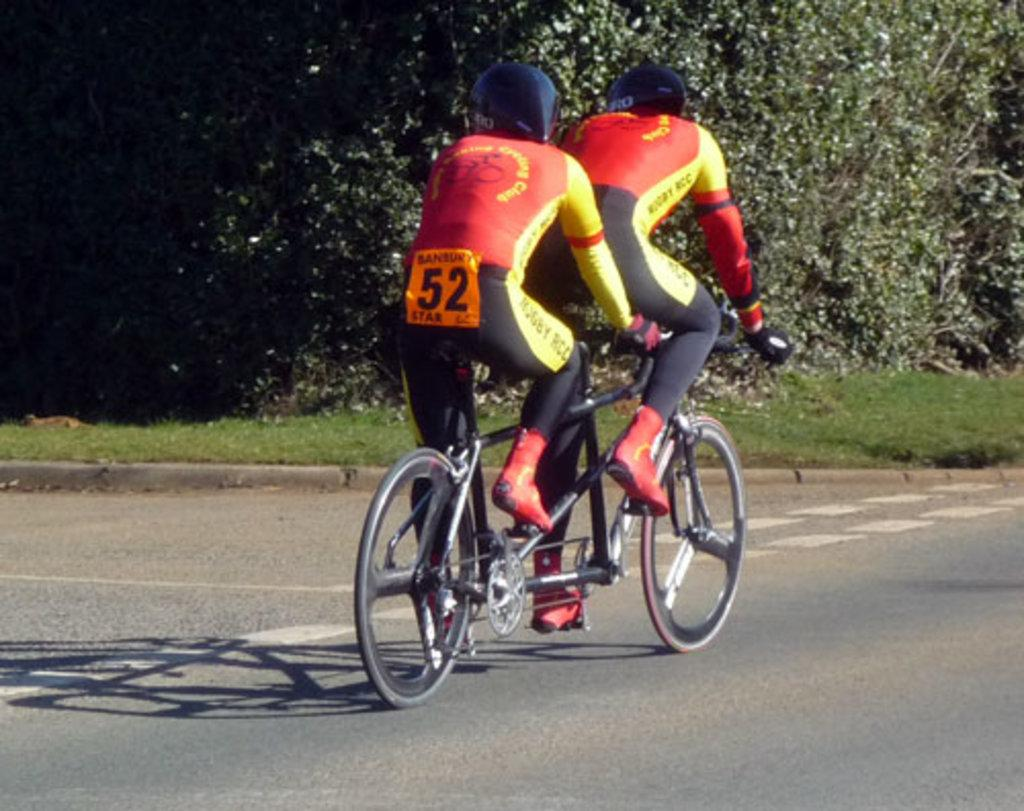How many people are in the image? There are two persons in the image. What are the two persons doing in the image? The two persons are riding a tandem bicycle. On what surface is the tandem bicycle located? The tandem bicycle is on a road surface. What can be seen in the background of the image? There are trees in the background of the image. What type of thumb can be seen holding the handlebar of the tandem bicycle? There is no thumb visible in the image; only the two persons riding the bicycle can be seen. Who is the partner of the person riding in the front of the tandem bicycle? The image does not provide information about the relationship between the two persons riding the bicycle, so it cannot be determined who their partners are. 